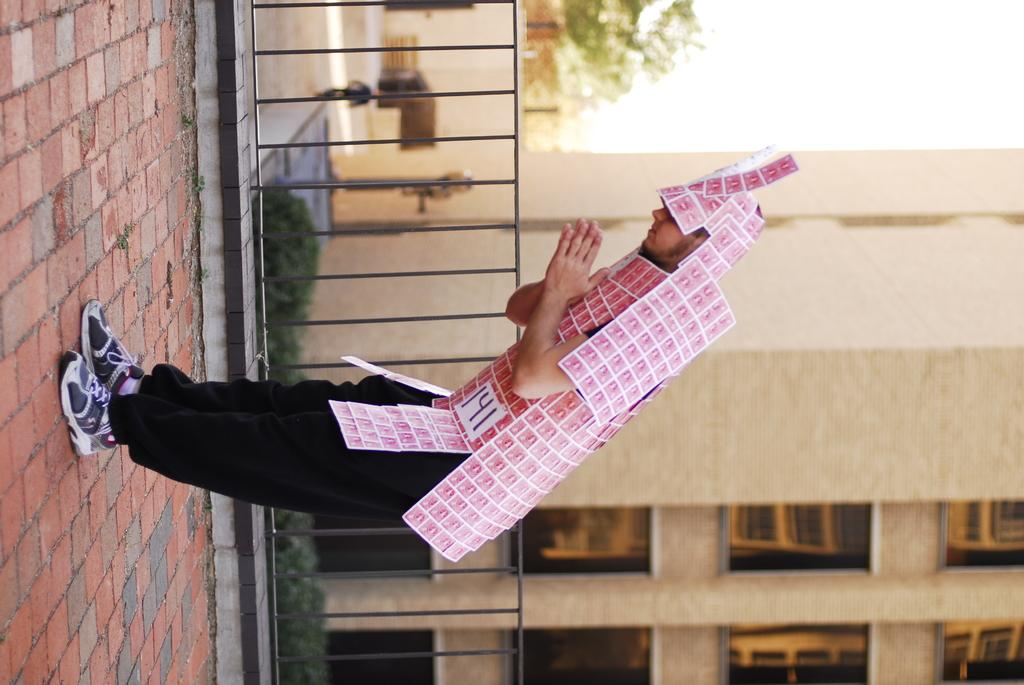What is the main subject of the image? There is a person in the image. What can be observed on the person's body? The person has stamps on them. What action is the person performing? The person is bowing. What can be seen in the background of the image? There is a building in the background of the image. What type of door can be seen in the image? There is no door present in the image; it only features a person with stamps and a building in the background. 